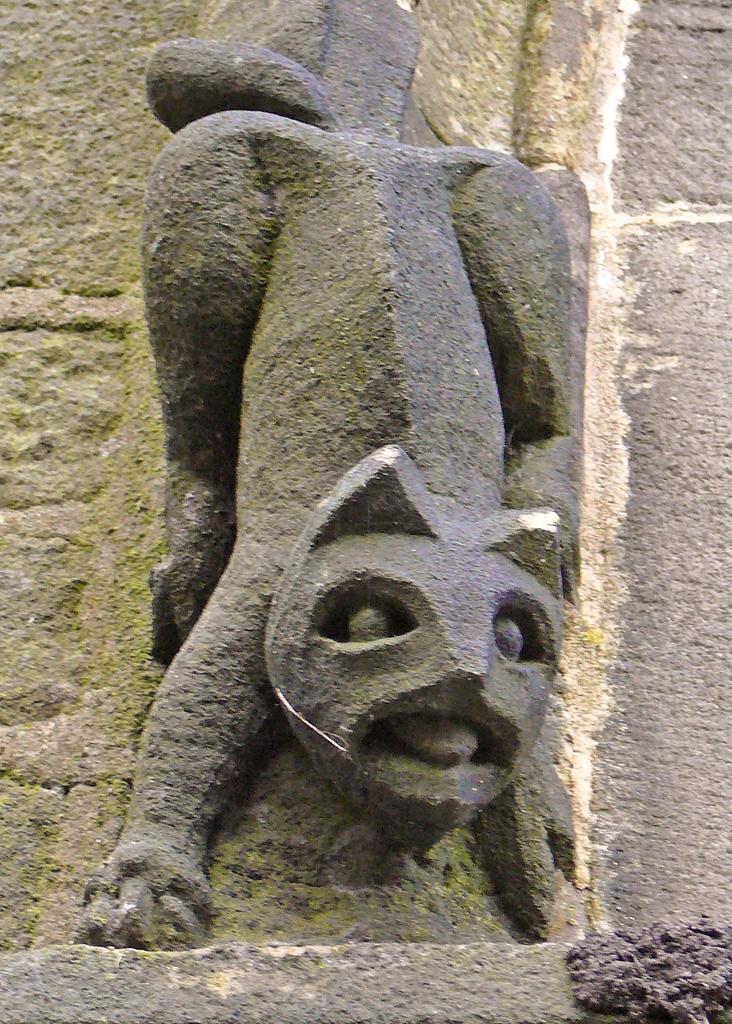In one or two sentences, can you explain what this image depicts? In this image I can see a sculpture of an animal. The background seems to be a wall. 